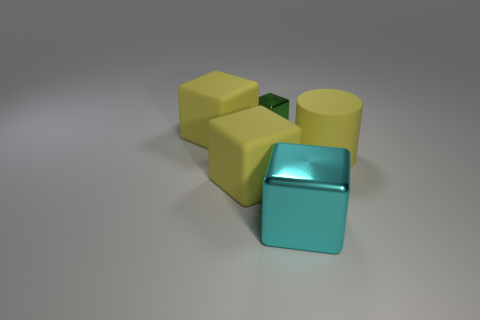There is a small metallic thing behind the cyan cube; is there a big matte cylinder that is to the left of it?
Give a very brief answer. No. What number of green things are small metallic blocks or big balls?
Your response must be concise. 1. The tiny block has what color?
Your response must be concise. Green. What size is the cube that is made of the same material as the green thing?
Offer a very short reply. Large. How many other shiny objects are the same shape as the tiny green metallic thing?
Provide a short and direct response. 1. Are there any other things that have the same size as the rubber cylinder?
Your response must be concise. Yes. What is the size of the rubber object to the right of the yellow matte block that is in front of the large yellow cylinder?
Ensure brevity in your answer.  Large. There is a cyan thing that is the same size as the yellow cylinder; what is its material?
Keep it short and to the point. Metal. Are there any tiny blocks that have the same material as the cylinder?
Keep it short and to the point. No. There is a matte cube behind the large thing that is right of the large block that is on the right side of the small green block; what is its color?
Your answer should be very brief. Yellow. 